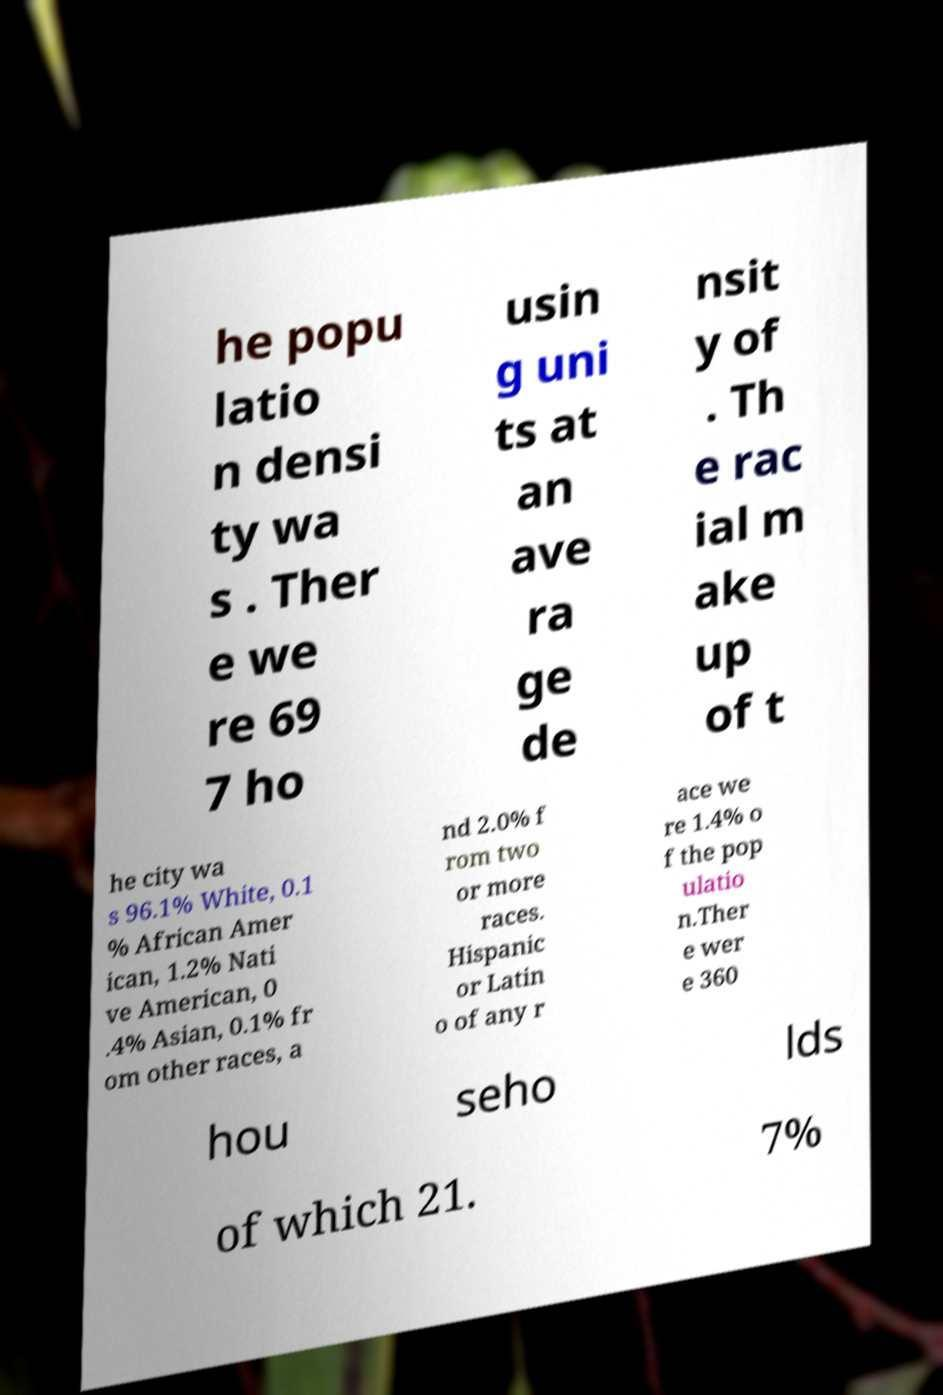Could you extract and type out the text from this image? he popu latio n densi ty wa s . Ther e we re 69 7 ho usin g uni ts at an ave ra ge de nsit y of . Th e rac ial m ake up of t he city wa s 96.1% White, 0.1 % African Amer ican, 1.2% Nati ve American, 0 .4% Asian, 0.1% fr om other races, a nd 2.0% f rom two or more races. Hispanic or Latin o of any r ace we re 1.4% o f the pop ulatio n.Ther e wer e 360 hou seho lds of which 21. 7% 